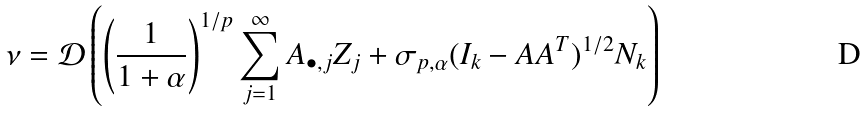<formula> <loc_0><loc_0><loc_500><loc_500>\nu = \mathcal { D } \left ( \left ( \frac { 1 } { 1 + \alpha } \right ) ^ { 1 / p } \sum _ { j = 1 } ^ { \infty } A _ { \bullet , j } Z _ { j } + \sigma _ { p , \alpha } ( I _ { k } - A A ^ { T } ) ^ { 1 / 2 } N _ { k } \right )</formula> 